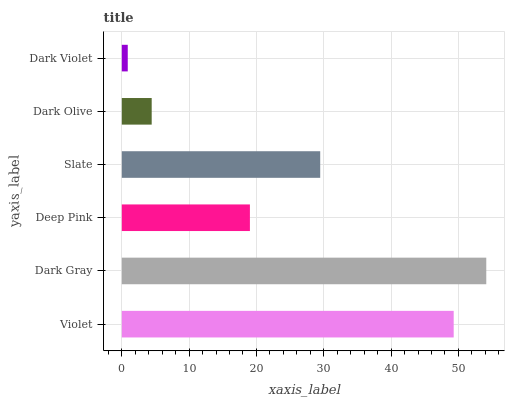Is Dark Violet the minimum?
Answer yes or no. Yes. Is Dark Gray the maximum?
Answer yes or no. Yes. Is Deep Pink the minimum?
Answer yes or no. No. Is Deep Pink the maximum?
Answer yes or no. No. Is Dark Gray greater than Deep Pink?
Answer yes or no. Yes. Is Deep Pink less than Dark Gray?
Answer yes or no. Yes. Is Deep Pink greater than Dark Gray?
Answer yes or no. No. Is Dark Gray less than Deep Pink?
Answer yes or no. No. Is Slate the high median?
Answer yes or no. Yes. Is Deep Pink the low median?
Answer yes or no. Yes. Is Dark Olive the high median?
Answer yes or no. No. Is Violet the low median?
Answer yes or no. No. 